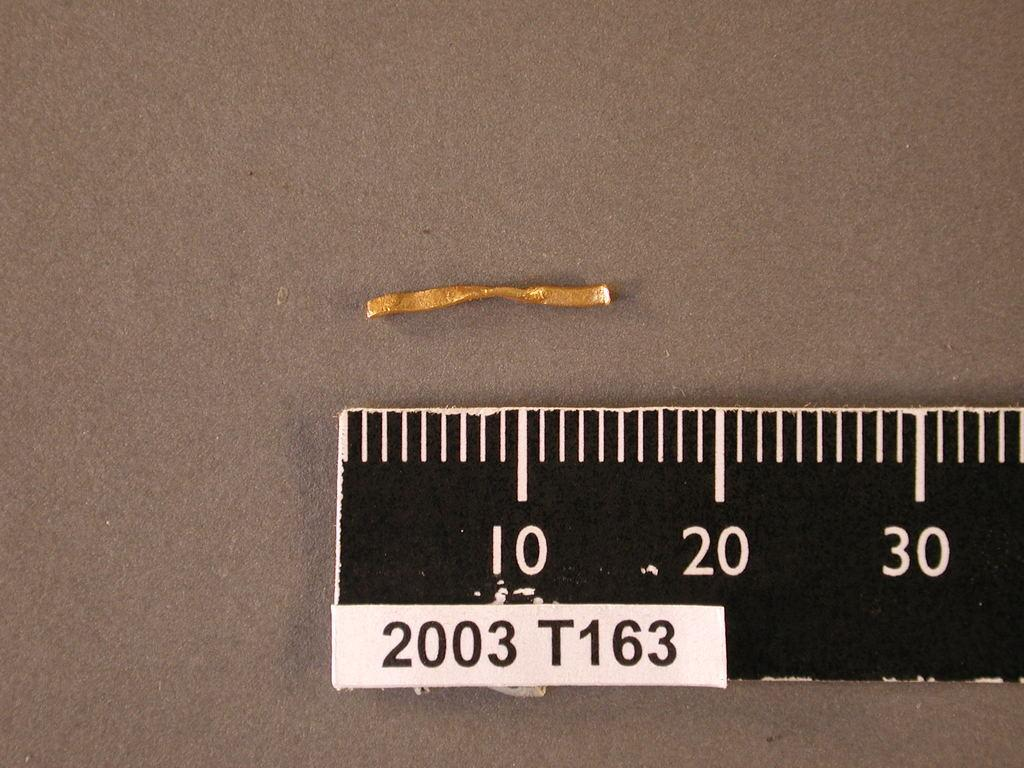<image>
Summarize the visual content of the image. a black ruler with 2003 T163 under the 10 